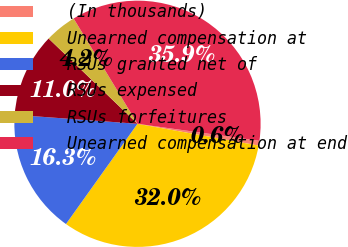Convert chart. <chart><loc_0><loc_0><loc_500><loc_500><pie_chart><fcel>(In thousands)<fcel>Unearned compensation at<fcel>RSUs granted net of<fcel>RSUs expensed<fcel>RSUs forfeitures<fcel>Unearned compensation at end<nl><fcel>0.62%<fcel>32.03%<fcel>16.3%<fcel>11.01%<fcel>4.15%<fcel>35.88%<nl></chart> 